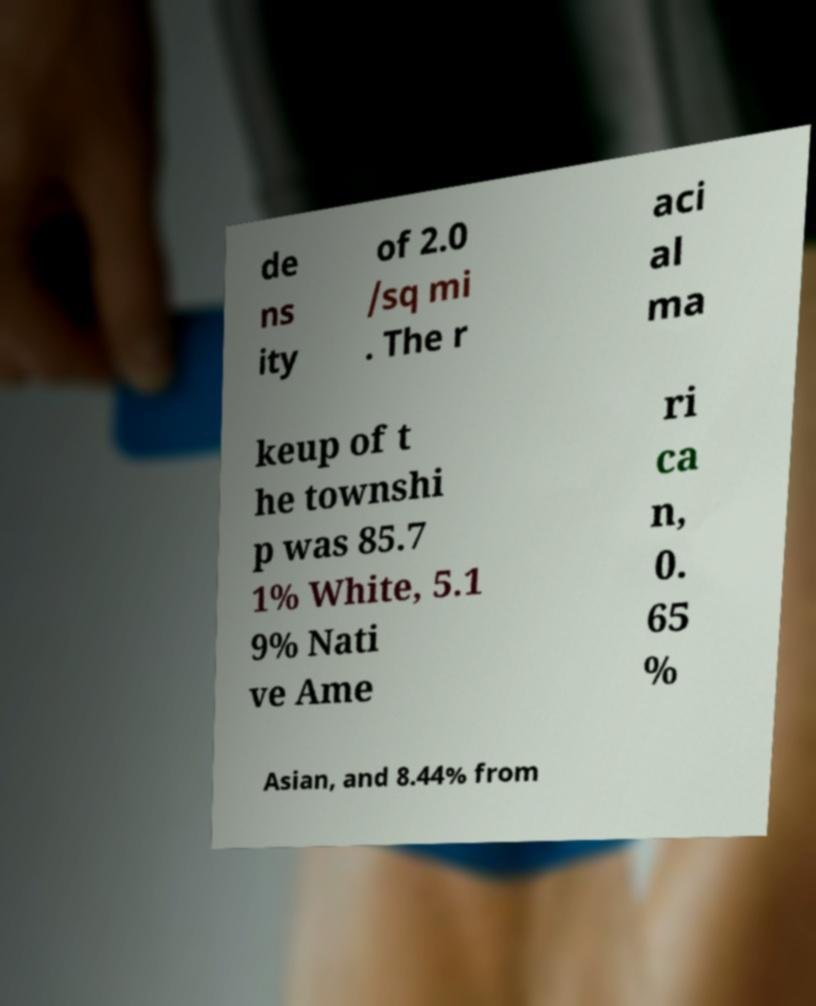What messages or text are displayed in this image? I need them in a readable, typed format. de ns ity of 2.0 /sq mi . The r aci al ma keup of t he townshi p was 85.7 1% White, 5.1 9% Nati ve Ame ri ca n, 0. 65 % Asian, and 8.44% from 